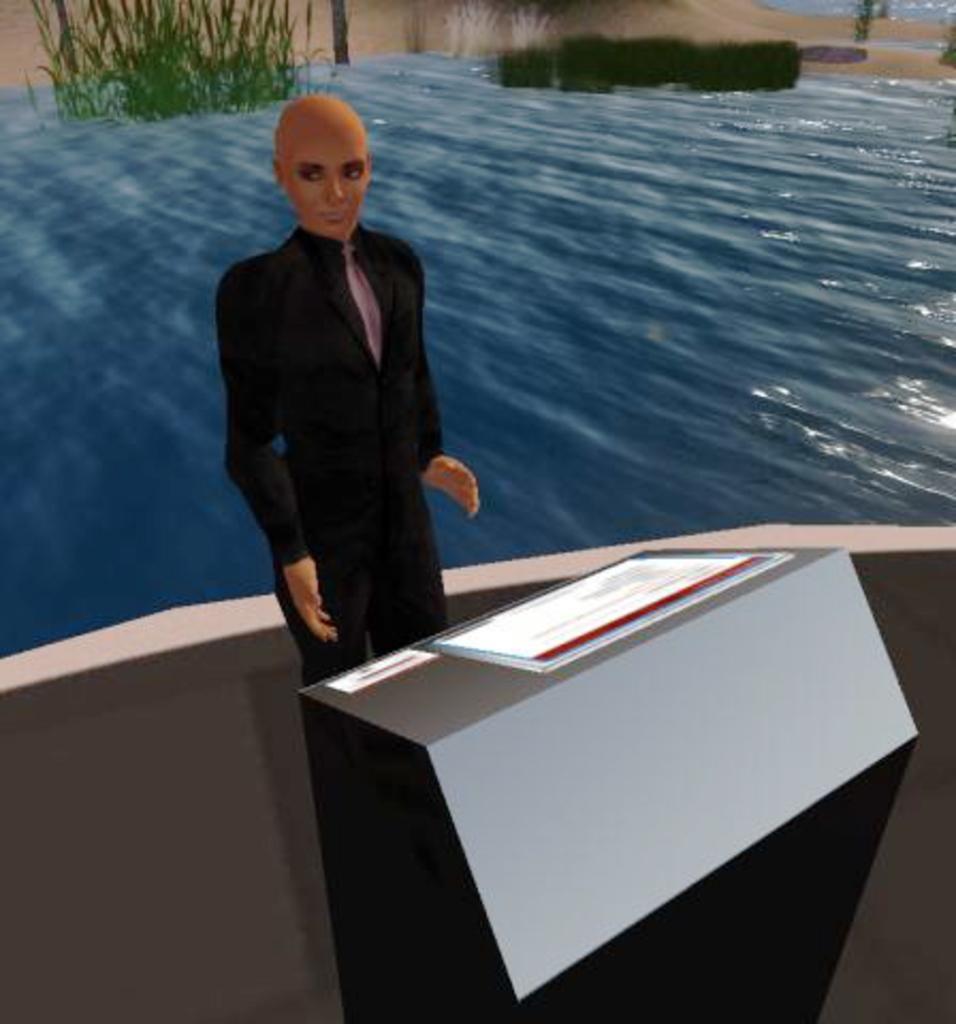Describe this image in one or two sentences. It is an animated picture. Here a person is standing behind the podium. Background we can see the water and plants. 